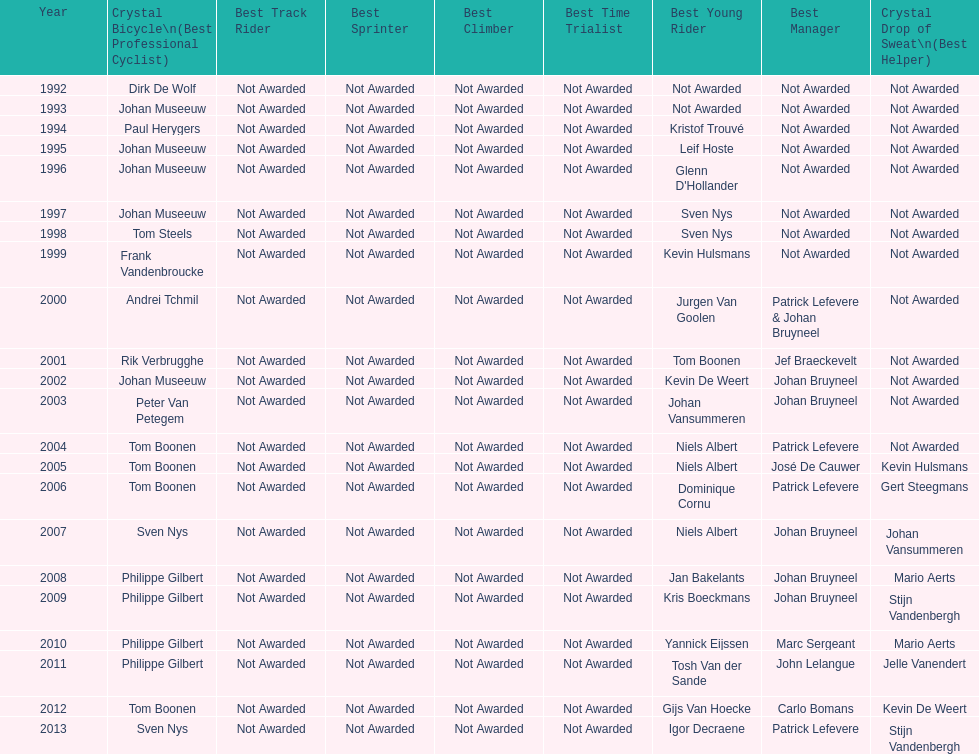Who has won the most best young rider awards? Niels Albert. Can you give me this table as a dict? {'header': ['Year', 'Crystal Bicycle\\n(Best Professional Cyclist)', 'Best Track Rider', 'Best Sprinter', 'Best Climber', 'Best Time Trialist', 'Best Young Rider', 'Best Manager', 'Crystal Drop of Sweat\\n(Best Helper)'], 'rows': [['1992', 'Dirk De Wolf', 'Not Awarded', 'Not Awarded', 'Not Awarded', 'Not Awarded', 'Not Awarded', 'Not Awarded', 'Not Awarded'], ['1993', 'Johan Museeuw', 'Not Awarded', 'Not Awarded', 'Not Awarded', 'Not Awarded', 'Not Awarded', 'Not Awarded', 'Not Awarded'], ['1994', 'Paul Herygers', 'Not Awarded', 'Not Awarded', 'Not Awarded', 'Not Awarded', 'Kristof Trouvé', 'Not Awarded', 'Not Awarded'], ['1995', 'Johan Museeuw', 'Not Awarded', 'Not Awarded', 'Not Awarded', 'Not Awarded', 'Leif Hoste', 'Not Awarded', 'Not Awarded'], ['1996', 'Johan Museeuw', 'Not Awarded', 'Not Awarded', 'Not Awarded', 'Not Awarded', "Glenn D'Hollander", 'Not Awarded', 'Not Awarded'], ['1997', 'Johan Museeuw', 'Not Awarded', 'Not Awarded', 'Not Awarded', 'Not Awarded', 'Sven Nys', 'Not Awarded', 'Not Awarded'], ['1998', 'Tom Steels', 'Not Awarded', 'Not Awarded', 'Not Awarded', 'Not Awarded', 'Sven Nys', 'Not Awarded', 'Not Awarded'], ['1999', 'Frank Vandenbroucke', 'Not Awarded', 'Not Awarded', 'Not Awarded', 'Not Awarded', 'Kevin Hulsmans', 'Not Awarded', 'Not Awarded'], ['2000', 'Andrei Tchmil', 'Not Awarded', 'Not Awarded', 'Not Awarded', 'Not Awarded', 'Jurgen Van Goolen', 'Patrick Lefevere & Johan Bruyneel', 'Not Awarded'], ['2001', 'Rik Verbrugghe', 'Not Awarded', 'Not Awarded', 'Not Awarded', 'Not Awarded', 'Tom Boonen', 'Jef Braeckevelt', 'Not Awarded'], ['2002', 'Johan Museeuw', 'Not Awarded', 'Not Awarded', 'Not Awarded', 'Not Awarded', 'Kevin De Weert', 'Johan Bruyneel', 'Not Awarded'], ['2003', 'Peter Van Petegem', 'Not Awarded', 'Not Awarded', 'Not Awarded', 'Not Awarded', 'Johan Vansummeren', 'Johan Bruyneel', 'Not Awarded'], ['2004', 'Tom Boonen', 'Not Awarded', 'Not Awarded', 'Not Awarded', 'Not Awarded', 'Niels Albert', 'Patrick Lefevere', 'Not Awarded'], ['2005', 'Tom Boonen', 'Not Awarded', 'Not Awarded', 'Not Awarded', 'Not Awarded', 'Niels Albert', 'José De Cauwer', 'Kevin Hulsmans'], ['2006', 'Tom Boonen', 'Not Awarded', 'Not Awarded', 'Not Awarded', 'Not Awarded', 'Dominique Cornu', 'Patrick Lefevere', 'Gert Steegmans'], ['2007', 'Sven Nys', 'Not Awarded', 'Not Awarded', 'Not Awarded', 'Not Awarded', 'Niels Albert', 'Johan Bruyneel', 'Johan Vansummeren'], ['2008', 'Philippe Gilbert', 'Not Awarded', 'Not Awarded', 'Not Awarded', 'Not Awarded', 'Jan Bakelants', 'Johan Bruyneel', 'Mario Aerts'], ['2009', 'Philippe Gilbert', 'Not Awarded', 'Not Awarded', 'Not Awarded', 'Not Awarded', 'Kris Boeckmans', 'Johan Bruyneel', 'Stijn Vandenbergh'], ['2010', 'Philippe Gilbert', 'Not Awarded', 'Not Awarded', 'Not Awarded', 'Not Awarded', 'Yannick Eijssen', 'Marc Sergeant', 'Mario Aerts'], ['2011', 'Philippe Gilbert', 'Not Awarded', 'Not Awarded', 'Not Awarded', 'Not Awarded', 'Tosh Van der Sande', 'John Lelangue', 'Jelle Vanendert'], ['2012', 'Tom Boonen', 'Not Awarded', 'Not Awarded', 'Not Awarded', 'Not Awarded', 'Gijs Van Hoecke', 'Carlo Bomans', 'Kevin De Weert'], ['2013', 'Sven Nys', 'Not Awarded', 'Not Awarded', 'Not Awarded', 'Not Awarded', 'Igor Decraene', 'Patrick Lefevere', 'Stijn Vandenbergh']]} 